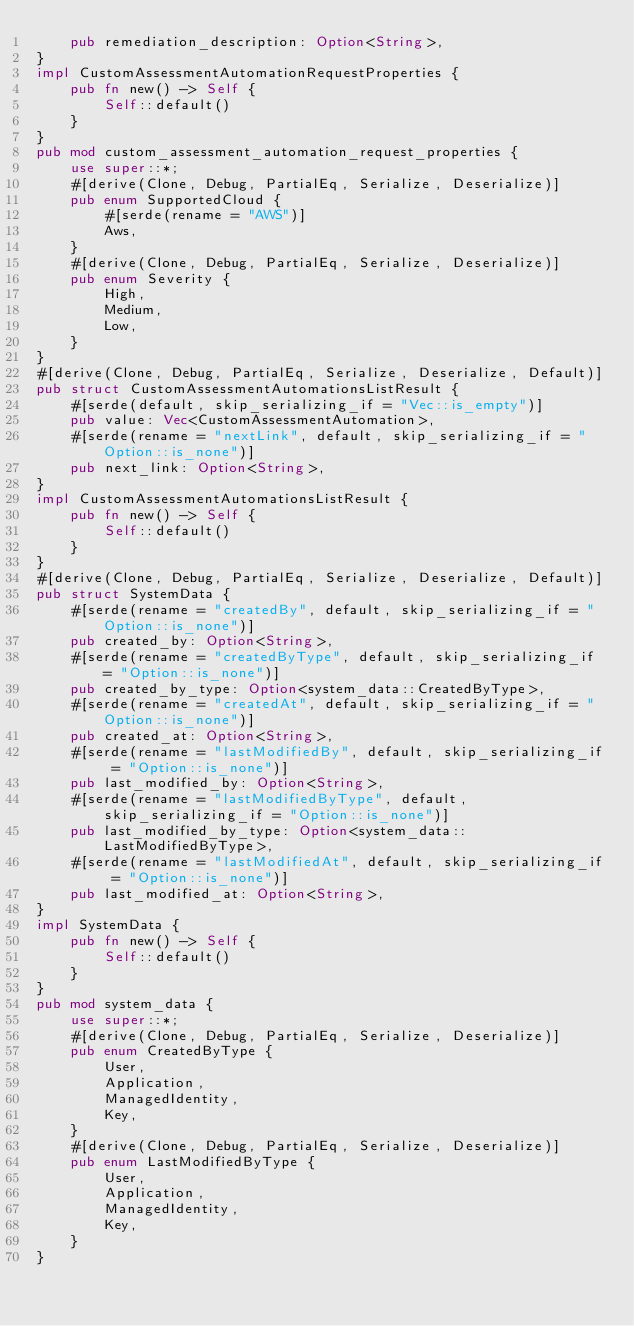Convert code to text. <code><loc_0><loc_0><loc_500><loc_500><_Rust_>    pub remediation_description: Option<String>,
}
impl CustomAssessmentAutomationRequestProperties {
    pub fn new() -> Self {
        Self::default()
    }
}
pub mod custom_assessment_automation_request_properties {
    use super::*;
    #[derive(Clone, Debug, PartialEq, Serialize, Deserialize)]
    pub enum SupportedCloud {
        #[serde(rename = "AWS")]
        Aws,
    }
    #[derive(Clone, Debug, PartialEq, Serialize, Deserialize)]
    pub enum Severity {
        High,
        Medium,
        Low,
    }
}
#[derive(Clone, Debug, PartialEq, Serialize, Deserialize, Default)]
pub struct CustomAssessmentAutomationsListResult {
    #[serde(default, skip_serializing_if = "Vec::is_empty")]
    pub value: Vec<CustomAssessmentAutomation>,
    #[serde(rename = "nextLink", default, skip_serializing_if = "Option::is_none")]
    pub next_link: Option<String>,
}
impl CustomAssessmentAutomationsListResult {
    pub fn new() -> Self {
        Self::default()
    }
}
#[derive(Clone, Debug, PartialEq, Serialize, Deserialize, Default)]
pub struct SystemData {
    #[serde(rename = "createdBy", default, skip_serializing_if = "Option::is_none")]
    pub created_by: Option<String>,
    #[serde(rename = "createdByType", default, skip_serializing_if = "Option::is_none")]
    pub created_by_type: Option<system_data::CreatedByType>,
    #[serde(rename = "createdAt", default, skip_serializing_if = "Option::is_none")]
    pub created_at: Option<String>,
    #[serde(rename = "lastModifiedBy", default, skip_serializing_if = "Option::is_none")]
    pub last_modified_by: Option<String>,
    #[serde(rename = "lastModifiedByType", default, skip_serializing_if = "Option::is_none")]
    pub last_modified_by_type: Option<system_data::LastModifiedByType>,
    #[serde(rename = "lastModifiedAt", default, skip_serializing_if = "Option::is_none")]
    pub last_modified_at: Option<String>,
}
impl SystemData {
    pub fn new() -> Self {
        Self::default()
    }
}
pub mod system_data {
    use super::*;
    #[derive(Clone, Debug, PartialEq, Serialize, Deserialize)]
    pub enum CreatedByType {
        User,
        Application,
        ManagedIdentity,
        Key,
    }
    #[derive(Clone, Debug, PartialEq, Serialize, Deserialize)]
    pub enum LastModifiedByType {
        User,
        Application,
        ManagedIdentity,
        Key,
    }
}
</code> 